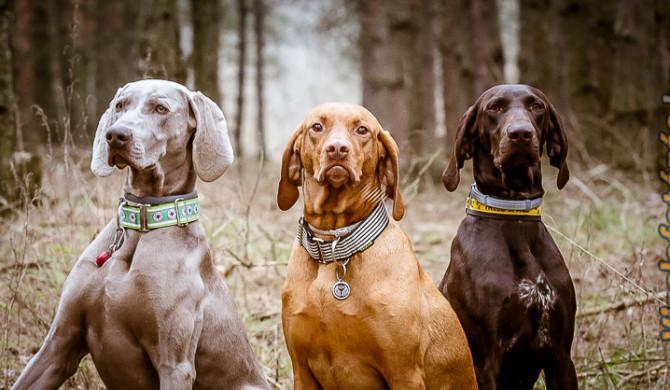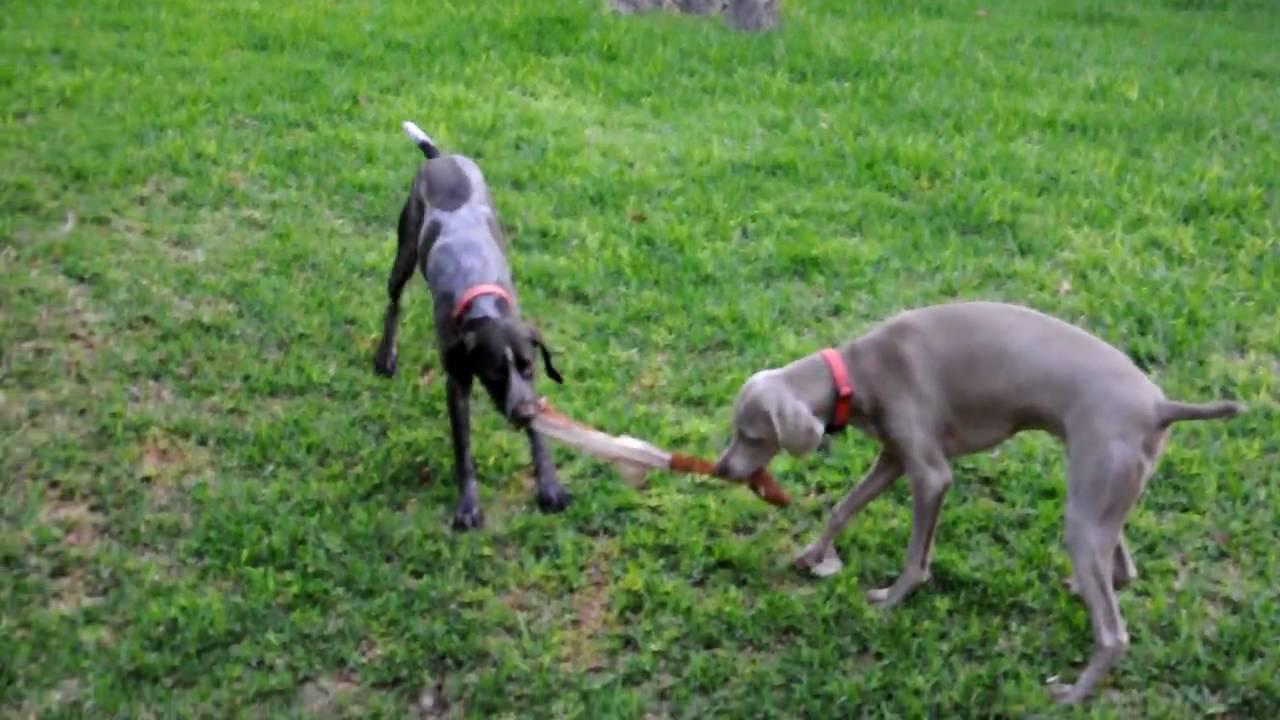The first image is the image on the left, the second image is the image on the right. Analyze the images presented: Is the assertion "At least three dogs are sitting nicely in one of the pictures." valid? Answer yes or no. Yes. The first image is the image on the left, the second image is the image on the right. Analyze the images presented: Is the assertion "There are three dogs looking attentively forward." valid? Answer yes or no. Yes. 